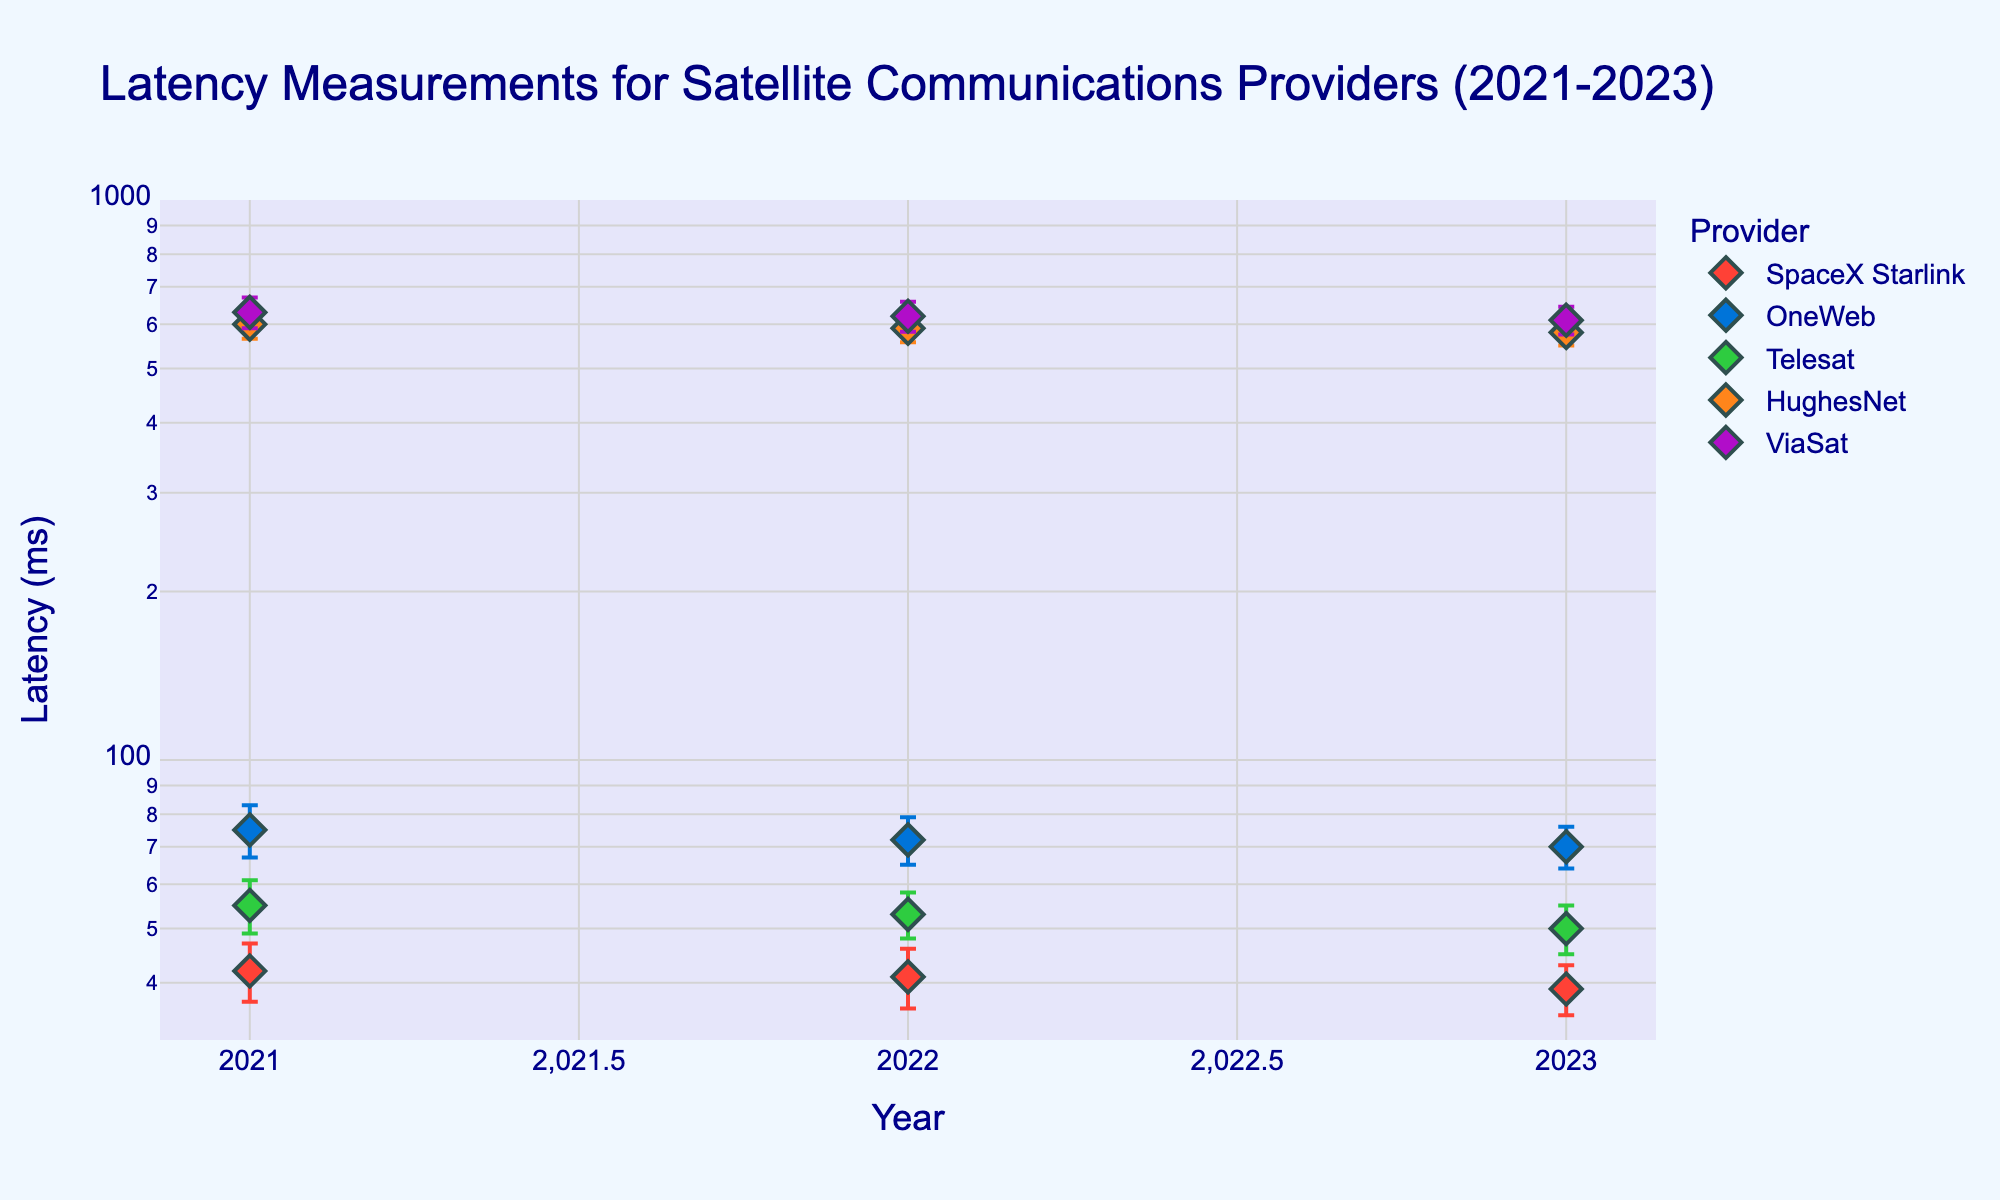What is the title of the plot? The title of the plot is located at the top and provides a description of what the plot represents. In this case, the title is 'Latency Measurements for Satellite Communications Providers (2021-2023)'.
Answer: Latency Measurements for Satellite Communications Providers (2021-2023) Which provider has the lowest average latency across the years? To determine this, we need to compare the average latency values for each provider. SpaceX Starlink has values of 42, 41, and 39 ms for 2021, 2022, and 2023 respectively, which averages to 40.67 ms. By comparison, the other providers have higher average latencies.
Answer: SpaceX Starlink What are the colors used to represent SpaceX Starlink and ViaSat in the plot? SpaceX Starlink is represented in a red color, while ViaSat is shown in a purple color. These colors help to visually distinguish the providers on the plot.
Answer: Red for SpaceX Starlink, Purple for ViaSat Which provider shows the greatest improvement in latency from 2021 to 2023? To find this, we calculate the difference in latency values from 2021 to 2023 for each provider. SpaceX Starlink improved from 42 ms to 39 ms (a reduction of 3 ms), OneWeb from 75 ms to 70 ms (a reduction of 5 ms), Telesat from 55 ms to 50 ms (a reduction of 5 ms), HughesNet from 600 ms to 580 ms (a reduction of 20 ms), and ViaSat from 630 ms to 610 ms (a reduction of 20 ms). HughesNet and ViaSat show the greatest improvement, both reducing by 20 ms.
Answer: HughesNet and ViaSat Between OneWeb and Telesat, which provider had a more stable latency over the years, based on standard deviation? The standard deviation for OneWeb is 8, 7, and 6 ms across the years 2021, 2022, and 2023 respectively. For Telesat, the values are 6, 5, and 5 ms. Comparing their standard deviations, Telesat has smaller fluctuations, indicating more stable latency.
Answer: Telesat What is the latency value of HughesNet in 2022, and how does it compare to Telesat's value of the same year? From the plot, HughesNet's latency in 2022 is 590 ms, while Telesat's latency is 53 ms. HughesNet's latency is significantly higher than Telesat's latency.
Answer: HughesNet: 590 ms, Telesat: 53 ms What is the trend in latency for ViaSat from 2021 to 2023? For ViaSat, the latency values show a decreasing trend from 630 ms in 2021, to 620 ms in 2022, and further to 610 ms in 2023, indicating a consistent improvement over the years.
Answer: Decreasing trend Which provider has the highest standard deviation in latency, and in which year? The highest standard deviation in the plot is 40 ms for ViaSat in 2021.
Answer: ViaSat in 2021 How does the latency of SpaceX Starlink in 2023 compare to their latency in 2021? SpaceX Starlink's latency decreased from 42 ms in 2021 to 39 ms in 2023, showing an improvement.
Answer: Improved (42 ms to 39 ms) In 2023, which provider has the lowest latency, and what is the numerical value? In 2023, SpaceX Starlink has the lowest latency with a value of 39 ms.
Answer: SpaceX Starlink, 39 ms 